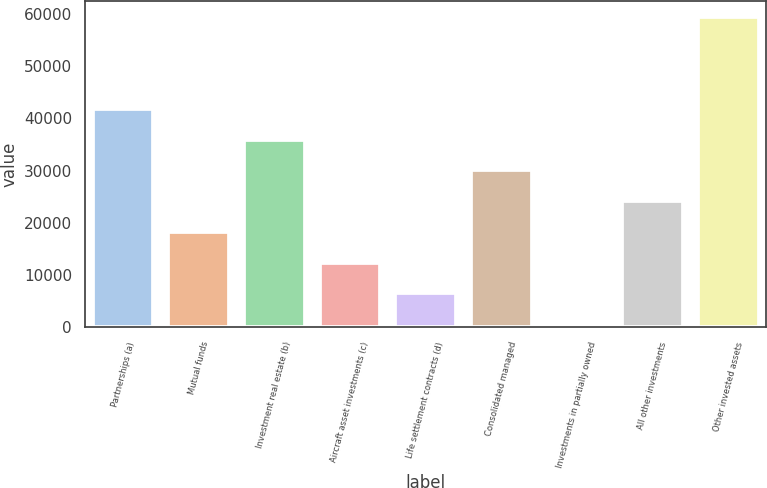Convert chart to OTSL. <chart><loc_0><loc_0><loc_500><loc_500><bar_chart><fcel>Partnerships (a)<fcel>Mutual funds<fcel>Investment real estate (b)<fcel>Aircraft asset investments (c)<fcel>Life settlement contracts (d)<fcel>Consolidated managed<fcel>Investments in partially owned<fcel>All other investments<fcel>Other invested assets<nl><fcel>41830.1<fcel>18300.9<fcel>35947.8<fcel>12418.6<fcel>6536.3<fcel>30065.5<fcel>654<fcel>24183.2<fcel>59477<nl></chart> 